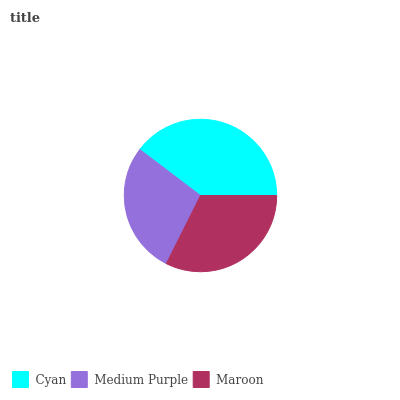Is Medium Purple the minimum?
Answer yes or no. Yes. Is Cyan the maximum?
Answer yes or no. Yes. Is Maroon the minimum?
Answer yes or no. No. Is Maroon the maximum?
Answer yes or no. No. Is Maroon greater than Medium Purple?
Answer yes or no. Yes. Is Medium Purple less than Maroon?
Answer yes or no. Yes. Is Medium Purple greater than Maroon?
Answer yes or no. No. Is Maroon less than Medium Purple?
Answer yes or no. No. Is Maroon the high median?
Answer yes or no. Yes. Is Maroon the low median?
Answer yes or no. Yes. Is Medium Purple the high median?
Answer yes or no. No. Is Medium Purple the low median?
Answer yes or no. No. 